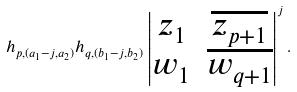<formula> <loc_0><loc_0><loc_500><loc_500>h _ { p , ( a _ { 1 } - j , a _ { 2 } ) } h _ { q , ( b _ { 1 } - j , b _ { 2 } ) } \left | \begin{matrix} z _ { 1 } & \overline { z _ { p + 1 } } \\ w _ { 1 } & \overline { w _ { q + 1 } } \end{matrix} \right | ^ { j } .</formula> 